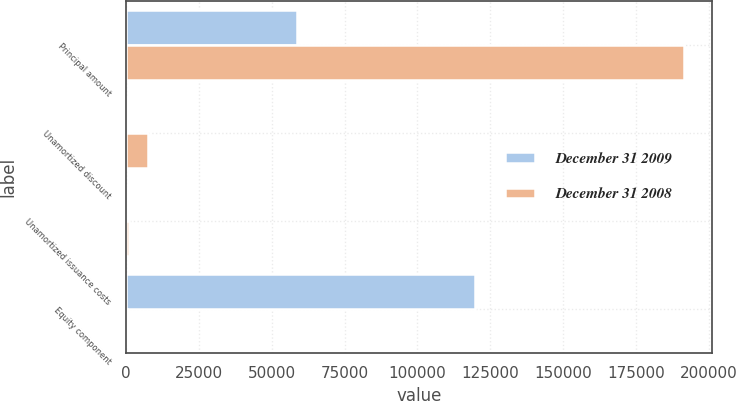Convert chart. <chart><loc_0><loc_0><loc_500><loc_500><stacked_bar_chart><ecel><fcel>Principal amount<fcel>Unamortized discount<fcel>Unamortized issuance costs<fcel>Equity component<nl><fcel>December 31 2009<fcel>58782<fcel>706<fcel>85<fcel>119724<nl><fcel>December 31 2008<fcel>191419<fcel>7682<fcel>942<fcel>222<nl></chart> 